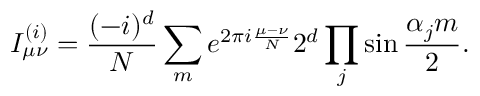<formula> <loc_0><loc_0><loc_500><loc_500>I _ { \mu \nu } ^ { ( i ) } = { \frac { ( - i ) ^ { d } } { N } } \sum _ { m } { e ^ { 2 \pi i { \frac { \mu - \nu } { N } } } 2 ^ { d } \prod _ { j } \sin { \frac { \alpha _ { j } m } { 2 } } } .</formula> 